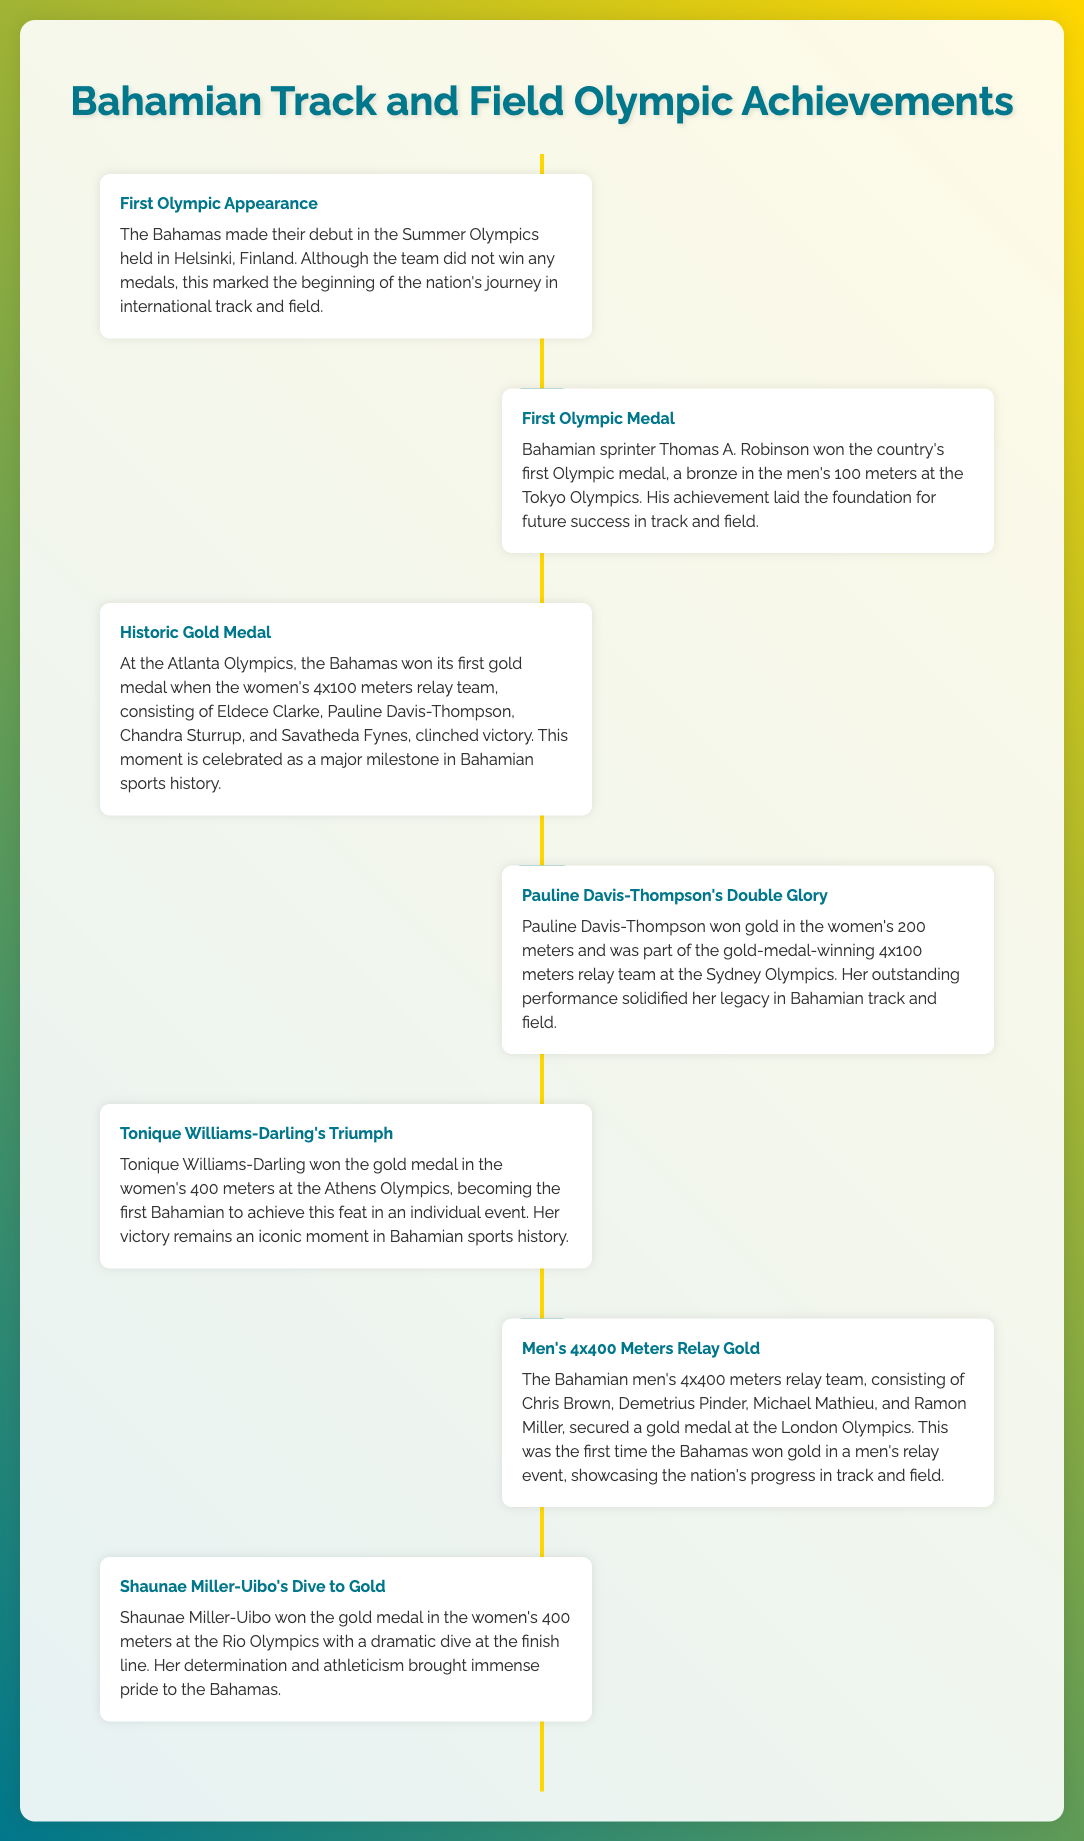What year did The Bahamas make their Olympic debut? The document states that The Bahamas made their Olympic debut in the year 1952.
Answer: 1952 Who was the first Bahamian to win an Olympic medal? The timeline highlights that Thomas A. Robinson won the first Olympic medal for The Bahamas in 1964.
Answer: Thomas A. Robinson What event did the women's 4x100 meters relay team win in 1996? The infographic mentions that the women's 4x100 meters relay team won gold at the Atlanta Olympics in 1996.
Answer: Gold What significant achievement did Pauline Davis-Thompson accomplish in 2000? According to the timeline, Pauline Davis-Thompson won gold in both the women's 200 meters and the 4x100 meters relay in 2000.
Answer: Double Gold What medal did Tonique Williams-Darling win at the Athens Olympics? The document indicates that Tonique Williams-Darling won a gold medal in the women's 400 meters at the Athens Olympics in 2008.
Answer: Gold In which year did the Bahamian men's 4x400 meters relay team secure a gold medal? The timeline reveals that the men's 4x400 meters relay team won a gold medal at the London Olympics in 2012.
Answer: 2012 What unique method did Shaunae Miller-Uibo use to win her Olympic race? The document states that Shaunae Miller-Uibo won her race with a dramatic dive at the finish line during the Rio Olympics in 2016.
Answer: Dive Which Olympics marked the first gold medal for The Bahamas? The timeline notes that the first gold medal for The Bahamas was won at the Atlanta Olympics in 1996.
Answer: Atlanta Olympics 